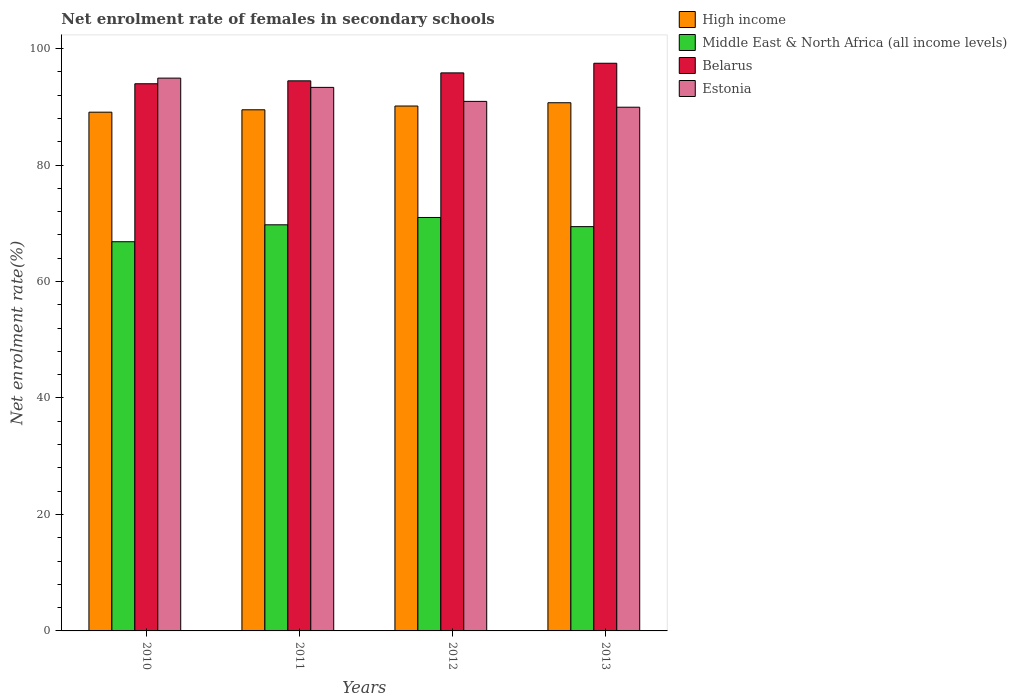How many different coloured bars are there?
Provide a short and direct response. 4. How many groups of bars are there?
Keep it short and to the point. 4. Are the number of bars per tick equal to the number of legend labels?
Your response must be concise. Yes. How many bars are there on the 3rd tick from the left?
Ensure brevity in your answer.  4. How many bars are there on the 1st tick from the right?
Offer a very short reply. 4. What is the label of the 2nd group of bars from the left?
Offer a very short reply. 2011. What is the net enrolment rate of females in secondary schools in Estonia in 2010?
Give a very brief answer. 94.93. Across all years, what is the maximum net enrolment rate of females in secondary schools in Belarus?
Provide a short and direct response. 97.48. Across all years, what is the minimum net enrolment rate of females in secondary schools in Belarus?
Your answer should be compact. 93.97. What is the total net enrolment rate of females in secondary schools in Middle East & North Africa (all income levels) in the graph?
Offer a very short reply. 277.01. What is the difference between the net enrolment rate of females in secondary schools in High income in 2010 and that in 2011?
Make the answer very short. -0.41. What is the difference between the net enrolment rate of females in secondary schools in High income in 2011 and the net enrolment rate of females in secondary schools in Middle East & North Africa (all income levels) in 2012?
Offer a very short reply. 18.49. What is the average net enrolment rate of females in secondary schools in High income per year?
Ensure brevity in your answer.  89.86. In the year 2010, what is the difference between the net enrolment rate of females in secondary schools in Middle East & North Africa (all income levels) and net enrolment rate of females in secondary schools in Belarus?
Make the answer very short. -27.13. What is the ratio of the net enrolment rate of females in secondary schools in High income in 2011 to that in 2012?
Provide a short and direct response. 0.99. What is the difference between the highest and the second highest net enrolment rate of females in secondary schools in High income?
Keep it short and to the point. 0.56. What is the difference between the highest and the lowest net enrolment rate of females in secondary schools in Middle East & North Africa (all income levels)?
Your answer should be compact. 4.16. Is the sum of the net enrolment rate of females in secondary schools in Estonia in 2010 and 2013 greater than the maximum net enrolment rate of females in secondary schools in Middle East & North Africa (all income levels) across all years?
Offer a very short reply. Yes. Is it the case that in every year, the sum of the net enrolment rate of females in secondary schools in High income and net enrolment rate of females in secondary schools in Middle East & North Africa (all income levels) is greater than the sum of net enrolment rate of females in secondary schools in Belarus and net enrolment rate of females in secondary schools in Estonia?
Ensure brevity in your answer.  No. What does the 3rd bar from the left in 2013 represents?
Provide a short and direct response. Belarus. What does the 2nd bar from the right in 2011 represents?
Keep it short and to the point. Belarus. How many bars are there?
Offer a terse response. 16. How many years are there in the graph?
Provide a short and direct response. 4. What is the difference between two consecutive major ticks on the Y-axis?
Your answer should be compact. 20. Are the values on the major ticks of Y-axis written in scientific E-notation?
Your answer should be compact. No. Does the graph contain any zero values?
Ensure brevity in your answer.  No. Does the graph contain grids?
Your response must be concise. No. Where does the legend appear in the graph?
Provide a succinct answer. Top right. How many legend labels are there?
Offer a terse response. 4. How are the legend labels stacked?
Make the answer very short. Vertical. What is the title of the graph?
Provide a short and direct response. Net enrolment rate of females in secondary schools. Does "Channel Islands" appear as one of the legend labels in the graph?
Provide a short and direct response. No. What is the label or title of the Y-axis?
Your response must be concise. Net enrolment rate(%). What is the Net enrolment rate(%) in High income in 2010?
Keep it short and to the point. 89.08. What is the Net enrolment rate(%) in Middle East & North Africa (all income levels) in 2010?
Keep it short and to the point. 66.84. What is the Net enrolment rate(%) of Belarus in 2010?
Keep it short and to the point. 93.97. What is the Net enrolment rate(%) of Estonia in 2010?
Keep it short and to the point. 94.93. What is the Net enrolment rate(%) in High income in 2011?
Make the answer very short. 89.49. What is the Net enrolment rate(%) of Middle East & North Africa (all income levels) in 2011?
Your answer should be compact. 69.74. What is the Net enrolment rate(%) of Belarus in 2011?
Provide a short and direct response. 94.47. What is the Net enrolment rate(%) of Estonia in 2011?
Offer a very short reply. 93.34. What is the Net enrolment rate(%) of High income in 2012?
Give a very brief answer. 90.14. What is the Net enrolment rate(%) of Middle East & North Africa (all income levels) in 2012?
Provide a short and direct response. 71. What is the Net enrolment rate(%) of Belarus in 2012?
Make the answer very short. 95.83. What is the Net enrolment rate(%) in Estonia in 2012?
Keep it short and to the point. 90.94. What is the Net enrolment rate(%) in High income in 2013?
Keep it short and to the point. 90.7. What is the Net enrolment rate(%) of Middle East & North Africa (all income levels) in 2013?
Your response must be concise. 69.43. What is the Net enrolment rate(%) of Belarus in 2013?
Provide a short and direct response. 97.48. What is the Net enrolment rate(%) in Estonia in 2013?
Provide a succinct answer. 89.94. Across all years, what is the maximum Net enrolment rate(%) of High income?
Your answer should be compact. 90.7. Across all years, what is the maximum Net enrolment rate(%) of Middle East & North Africa (all income levels)?
Your response must be concise. 71. Across all years, what is the maximum Net enrolment rate(%) of Belarus?
Ensure brevity in your answer.  97.48. Across all years, what is the maximum Net enrolment rate(%) in Estonia?
Give a very brief answer. 94.93. Across all years, what is the minimum Net enrolment rate(%) in High income?
Provide a short and direct response. 89.08. Across all years, what is the minimum Net enrolment rate(%) in Middle East & North Africa (all income levels)?
Your answer should be compact. 66.84. Across all years, what is the minimum Net enrolment rate(%) of Belarus?
Your answer should be compact. 93.97. Across all years, what is the minimum Net enrolment rate(%) in Estonia?
Make the answer very short. 89.94. What is the total Net enrolment rate(%) in High income in the graph?
Make the answer very short. 359.42. What is the total Net enrolment rate(%) of Middle East & North Africa (all income levels) in the graph?
Provide a succinct answer. 277.01. What is the total Net enrolment rate(%) in Belarus in the graph?
Give a very brief answer. 381.75. What is the total Net enrolment rate(%) in Estonia in the graph?
Keep it short and to the point. 369.15. What is the difference between the Net enrolment rate(%) of High income in 2010 and that in 2011?
Give a very brief answer. -0.41. What is the difference between the Net enrolment rate(%) in Middle East & North Africa (all income levels) in 2010 and that in 2011?
Offer a terse response. -2.91. What is the difference between the Net enrolment rate(%) of Belarus in 2010 and that in 2011?
Provide a short and direct response. -0.5. What is the difference between the Net enrolment rate(%) in Estonia in 2010 and that in 2011?
Offer a very short reply. 1.59. What is the difference between the Net enrolment rate(%) in High income in 2010 and that in 2012?
Your response must be concise. -1.06. What is the difference between the Net enrolment rate(%) in Middle East & North Africa (all income levels) in 2010 and that in 2012?
Make the answer very short. -4.16. What is the difference between the Net enrolment rate(%) of Belarus in 2010 and that in 2012?
Offer a very short reply. -1.87. What is the difference between the Net enrolment rate(%) of Estonia in 2010 and that in 2012?
Provide a short and direct response. 4. What is the difference between the Net enrolment rate(%) of High income in 2010 and that in 2013?
Your answer should be compact. -1.62. What is the difference between the Net enrolment rate(%) in Middle East & North Africa (all income levels) in 2010 and that in 2013?
Make the answer very short. -2.59. What is the difference between the Net enrolment rate(%) of Belarus in 2010 and that in 2013?
Provide a succinct answer. -3.52. What is the difference between the Net enrolment rate(%) in Estonia in 2010 and that in 2013?
Offer a terse response. 5. What is the difference between the Net enrolment rate(%) in High income in 2011 and that in 2012?
Make the answer very short. -0.65. What is the difference between the Net enrolment rate(%) in Middle East & North Africa (all income levels) in 2011 and that in 2012?
Make the answer very short. -1.26. What is the difference between the Net enrolment rate(%) in Belarus in 2011 and that in 2012?
Provide a short and direct response. -1.36. What is the difference between the Net enrolment rate(%) in Estonia in 2011 and that in 2012?
Provide a succinct answer. 2.4. What is the difference between the Net enrolment rate(%) of High income in 2011 and that in 2013?
Your response must be concise. -1.21. What is the difference between the Net enrolment rate(%) in Middle East & North Africa (all income levels) in 2011 and that in 2013?
Give a very brief answer. 0.31. What is the difference between the Net enrolment rate(%) of Belarus in 2011 and that in 2013?
Your answer should be compact. -3.02. What is the difference between the Net enrolment rate(%) of Estonia in 2011 and that in 2013?
Keep it short and to the point. 3.4. What is the difference between the Net enrolment rate(%) in High income in 2012 and that in 2013?
Offer a very short reply. -0.56. What is the difference between the Net enrolment rate(%) in Middle East & North Africa (all income levels) in 2012 and that in 2013?
Offer a terse response. 1.57. What is the difference between the Net enrolment rate(%) of Belarus in 2012 and that in 2013?
Your answer should be very brief. -1.65. What is the difference between the Net enrolment rate(%) in Estonia in 2012 and that in 2013?
Offer a terse response. 1. What is the difference between the Net enrolment rate(%) in High income in 2010 and the Net enrolment rate(%) in Middle East & North Africa (all income levels) in 2011?
Give a very brief answer. 19.34. What is the difference between the Net enrolment rate(%) of High income in 2010 and the Net enrolment rate(%) of Belarus in 2011?
Provide a short and direct response. -5.38. What is the difference between the Net enrolment rate(%) in High income in 2010 and the Net enrolment rate(%) in Estonia in 2011?
Offer a very short reply. -4.26. What is the difference between the Net enrolment rate(%) in Middle East & North Africa (all income levels) in 2010 and the Net enrolment rate(%) in Belarus in 2011?
Ensure brevity in your answer.  -27.63. What is the difference between the Net enrolment rate(%) of Middle East & North Africa (all income levels) in 2010 and the Net enrolment rate(%) of Estonia in 2011?
Make the answer very short. -26.51. What is the difference between the Net enrolment rate(%) in Belarus in 2010 and the Net enrolment rate(%) in Estonia in 2011?
Your response must be concise. 0.62. What is the difference between the Net enrolment rate(%) in High income in 2010 and the Net enrolment rate(%) in Middle East & North Africa (all income levels) in 2012?
Keep it short and to the point. 18.08. What is the difference between the Net enrolment rate(%) of High income in 2010 and the Net enrolment rate(%) of Belarus in 2012?
Keep it short and to the point. -6.75. What is the difference between the Net enrolment rate(%) of High income in 2010 and the Net enrolment rate(%) of Estonia in 2012?
Offer a very short reply. -1.85. What is the difference between the Net enrolment rate(%) of Middle East & North Africa (all income levels) in 2010 and the Net enrolment rate(%) of Belarus in 2012?
Ensure brevity in your answer.  -28.99. What is the difference between the Net enrolment rate(%) of Middle East & North Africa (all income levels) in 2010 and the Net enrolment rate(%) of Estonia in 2012?
Offer a terse response. -24.1. What is the difference between the Net enrolment rate(%) in Belarus in 2010 and the Net enrolment rate(%) in Estonia in 2012?
Offer a terse response. 3.03. What is the difference between the Net enrolment rate(%) of High income in 2010 and the Net enrolment rate(%) of Middle East & North Africa (all income levels) in 2013?
Give a very brief answer. 19.66. What is the difference between the Net enrolment rate(%) of High income in 2010 and the Net enrolment rate(%) of Belarus in 2013?
Your answer should be very brief. -8.4. What is the difference between the Net enrolment rate(%) of High income in 2010 and the Net enrolment rate(%) of Estonia in 2013?
Ensure brevity in your answer.  -0.85. What is the difference between the Net enrolment rate(%) of Middle East & North Africa (all income levels) in 2010 and the Net enrolment rate(%) of Belarus in 2013?
Offer a terse response. -30.65. What is the difference between the Net enrolment rate(%) in Middle East & North Africa (all income levels) in 2010 and the Net enrolment rate(%) in Estonia in 2013?
Offer a very short reply. -23.1. What is the difference between the Net enrolment rate(%) in Belarus in 2010 and the Net enrolment rate(%) in Estonia in 2013?
Your response must be concise. 4.03. What is the difference between the Net enrolment rate(%) of High income in 2011 and the Net enrolment rate(%) of Middle East & North Africa (all income levels) in 2012?
Give a very brief answer. 18.49. What is the difference between the Net enrolment rate(%) of High income in 2011 and the Net enrolment rate(%) of Belarus in 2012?
Keep it short and to the point. -6.34. What is the difference between the Net enrolment rate(%) in High income in 2011 and the Net enrolment rate(%) in Estonia in 2012?
Offer a very short reply. -1.44. What is the difference between the Net enrolment rate(%) of Middle East & North Africa (all income levels) in 2011 and the Net enrolment rate(%) of Belarus in 2012?
Your answer should be very brief. -26.09. What is the difference between the Net enrolment rate(%) of Middle East & North Africa (all income levels) in 2011 and the Net enrolment rate(%) of Estonia in 2012?
Your response must be concise. -21.19. What is the difference between the Net enrolment rate(%) of Belarus in 2011 and the Net enrolment rate(%) of Estonia in 2012?
Give a very brief answer. 3.53. What is the difference between the Net enrolment rate(%) of High income in 2011 and the Net enrolment rate(%) of Middle East & North Africa (all income levels) in 2013?
Offer a very short reply. 20.06. What is the difference between the Net enrolment rate(%) of High income in 2011 and the Net enrolment rate(%) of Belarus in 2013?
Make the answer very short. -7.99. What is the difference between the Net enrolment rate(%) in High income in 2011 and the Net enrolment rate(%) in Estonia in 2013?
Your answer should be very brief. -0.44. What is the difference between the Net enrolment rate(%) in Middle East & North Africa (all income levels) in 2011 and the Net enrolment rate(%) in Belarus in 2013?
Provide a short and direct response. -27.74. What is the difference between the Net enrolment rate(%) in Middle East & North Africa (all income levels) in 2011 and the Net enrolment rate(%) in Estonia in 2013?
Provide a succinct answer. -20.19. What is the difference between the Net enrolment rate(%) in Belarus in 2011 and the Net enrolment rate(%) in Estonia in 2013?
Your answer should be compact. 4.53. What is the difference between the Net enrolment rate(%) in High income in 2012 and the Net enrolment rate(%) in Middle East & North Africa (all income levels) in 2013?
Provide a succinct answer. 20.71. What is the difference between the Net enrolment rate(%) of High income in 2012 and the Net enrolment rate(%) of Belarus in 2013?
Offer a terse response. -7.34. What is the difference between the Net enrolment rate(%) in High income in 2012 and the Net enrolment rate(%) in Estonia in 2013?
Ensure brevity in your answer.  0.2. What is the difference between the Net enrolment rate(%) of Middle East & North Africa (all income levels) in 2012 and the Net enrolment rate(%) of Belarus in 2013?
Offer a very short reply. -26.49. What is the difference between the Net enrolment rate(%) of Middle East & North Africa (all income levels) in 2012 and the Net enrolment rate(%) of Estonia in 2013?
Provide a short and direct response. -18.94. What is the difference between the Net enrolment rate(%) in Belarus in 2012 and the Net enrolment rate(%) in Estonia in 2013?
Provide a short and direct response. 5.89. What is the average Net enrolment rate(%) in High income per year?
Make the answer very short. 89.86. What is the average Net enrolment rate(%) of Middle East & North Africa (all income levels) per year?
Offer a very short reply. 69.25. What is the average Net enrolment rate(%) in Belarus per year?
Your answer should be compact. 95.44. What is the average Net enrolment rate(%) of Estonia per year?
Make the answer very short. 92.29. In the year 2010, what is the difference between the Net enrolment rate(%) of High income and Net enrolment rate(%) of Middle East & North Africa (all income levels)?
Give a very brief answer. 22.25. In the year 2010, what is the difference between the Net enrolment rate(%) in High income and Net enrolment rate(%) in Belarus?
Keep it short and to the point. -4.88. In the year 2010, what is the difference between the Net enrolment rate(%) in High income and Net enrolment rate(%) in Estonia?
Offer a very short reply. -5.85. In the year 2010, what is the difference between the Net enrolment rate(%) of Middle East & North Africa (all income levels) and Net enrolment rate(%) of Belarus?
Your response must be concise. -27.13. In the year 2010, what is the difference between the Net enrolment rate(%) of Middle East & North Africa (all income levels) and Net enrolment rate(%) of Estonia?
Give a very brief answer. -28.1. In the year 2010, what is the difference between the Net enrolment rate(%) in Belarus and Net enrolment rate(%) in Estonia?
Your response must be concise. -0.97. In the year 2011, what is the difference between the Net enrolment rate(%) in High income and Net enrolment rate(%) in Middle East & North Africa (all income levels)?
Your response must be concise. 19.75. In the year 2011, what is the difference between the Net enrolment rate(%) of High income and Net enrolment rate(%) of Belarus?
Give a very brief answer. -4.97. In the year 2011, what is the difference between the Net enrolment rate(%) of High income and Net enrolment rate(%) of Estonia?
Give a very brief answer. -3.85. In the year 2011, what is the difference between the Net enrolment rate(%) in Middle East & North Africa (all income levels) and Net enrolment rate(%) in Belarus?
Offer a very short reply. -24.72. In the year 2011, what is the difference between the Net enrolment rate(%) of Middle East & North Africa (all income levels) and Net enrolment rate(%) of Estonia?
Your answer should be compact. -23.6. In the year 2011, what is the difference between the Net enrolment rate(%) in Belarus and Net enrolment rate(%) in Estonia?
Provide a succinct answer. 1.13. In the year 2012, what is the difference between the Net enrolment rate(%) in High income and Net enrolment rate(%) in Middle East & North Africa (all income levels)?
Provide a succinct answer. 19.14. In the year 2012, what is the difference between the Net enrolment rate(%) of High income and Net enrolment rate(%) of Belarus?
Offer a very short reply. -5.69. In the year 2012, what is the difference between the Net enrolment rate(%) in High income and Net enrolment rate(%) in Estonia?
Your response must be concise. -0.8. In the year 2012, what is the difference between the Net enrolment rate(%) of Middle East & North Africa (all income levels) and Net enrolment rate(%) of Belarus?
Offer a very short reply. -24.83. In the year 2012, what is the difference between the Net enrolment rate(%) of Middle East & North Africa (all income levels) and Net enrolment rate(%) of Estonia?
Your answer should be compact. -19.94. In the year 2012, what is the difference between the Net enrolment rate(%) of Belarus and Net enrolment rate(%) of Estonia?
Your response must be concise. 4.89. In the year 2013, what is the difference between the Net enrolment rate(%) of High income and Net enrolment rate(%) of Middle East & North Africa (all income levels)?
Ensure brevity in your answer.  21.28. In the year 2013, what is the difference between the Net enrolment rate(%) in High income and Net enrolment rate(%) in Belarus?
Offer a very short reply. -6.78. In the year 2013, what is the difference between the Net enrolment rate(%) of High income and Net enrolment rate(%) of Estonia?
Provide a short and direct response. 0.77. In the year 2013, what is the difference between the Net enrolment rate(%) in Middle East & North Africa (all income levels) and Net enrolment rate(%) in Belarus?
Your response must be concise. -28.06. In the year 2013, what is the difference between the Net enrolment rate(%) of Middle East & North Africa (all income levels) and Net enrolment rate(%) of Estonia?
Offer a terse response. -20.51. In the year 2013, what is the difference between the Net enrolment rate(%) in Belarus and Net enrolment rate(%) in Estonia?
Provide a succinct answer. 7.55. What is the ratio of the Net enrolment rate(%) of Middle East & North Africa (all income levels) in 2010 to that in 2011?
Your answer should be very brief. 0.96. What is the ratio of the Net enrolment rate(%) of Estonia in 2010 to that in 2011?
Provide a succinct answer. 1.02. What is the ratio of the Net enrolment rate(%) in High income in 2010 to that in 2012?
Offer a terse response. 0.99. What is the ratio of the Net enrolment rate(%) of Middle East & North Africa (all income levels) in 2010 to that in 2012?
Offer a terse response. 0.94. What is the ratio of the Net enrolment rate(%) in Belarus in 2010 to that in 2012?
Your answer should be compact. 0.98. What is the ratio of the Net enrolment rate(%) of Estonia in 2010 to that in 2012?
Your answer should be compact. 1.04. What is the ratio of the Net enrolment rate(%) in High income in 2010 to that in 2013?
Ensure brevity in your answer.  0.98. What is the ratio of the Net enrolment rate(%) in Middle East & North Africa (all income levels) in 2010 to that in 2013?
Make the answer very short. 0.96. What is the ratio of the Net enrolment rate(%) of Belarus in 2010 to that in 2013?
Your answer should be very brief. 0.96. What is the ratio of the Net enrolment rate(%) of Estonia in 2010 to that in 2013?
Your answer should be very brief. 1.06. What is the ratio of the Net enrolment rate(%) in Middle East & North Africa (all income levels) in 2011 to that in 2012?
Provide a short and direct response. 0.98. What is the ratio of the Net enrolment rate(%) in Belarus in 2011 to that in 2012?
Make the answer very short. 0.99. What is the ratio of the Net enrolment rate(%) in Estonia in 2011 to that in 2012?
Provide a succinct answer. 1.03. What is the ratio of the Net enrolment rate(%) of High income in 2011 to that in 2013?
Offer a terse response. 0.99. What is the ratio of the Net enrolment rate(%) of Belarus in 2011 to that in 2013?
Offer a terse response. 0.97. What is the ratio of the Net enrolment rate(%) in Estonia in 2011 to that in 2013?
Offer a very short reply. 1.04. What is the ratio of the Net enrolment rate(%) in High income in 2012 to that in 2013?
Keep it short and to the point. 0.99. What is the ratio of the Net enrolment rate(%) of Middle East & North Africa (all income levels) in 2012 to that in 2013?
Your answer should be compact. 1.02. What is the ratio of the Net enrolment rate(%) in Estonia in 2012 to that in 2013?
Offer a terse response. 1.01. What is the difference between the highest and the second highest Net enrolment rate(%) of High income?
Ensure brevity in your answer.  0.56. What is the difference between the highest and the second highest Net enrolment rate(%) in Middle East & North Africa (all income levels)?
Offer a very short reply. 1.26. What is the difference between the highest and the second highest Net enrolment rate(%) in Belarus?
Provide a succinct answer. 1.65. What is the difference between the highest and the second highest Net enrolment rate(%) in Estonia?
Offer a terse response. 1.59. What is the difference between the highest and the lowest Net enrolment rate(%) in High income?
Give a very brief answer. 1.62. What is the difference between the highest and the lowest Net enrolment rate(%) in Middle East & North Africa (all income levels)?
Offer a very short reply. 4.16. What is the difference between the highest and the lowest Net enrolment rate(%) in Belarus?
Your response must be concise. 3.52. What is the difference between the highest and the lowest Net enrolment rate(%) in Estonia?
Keep it short and to the point. 5. 